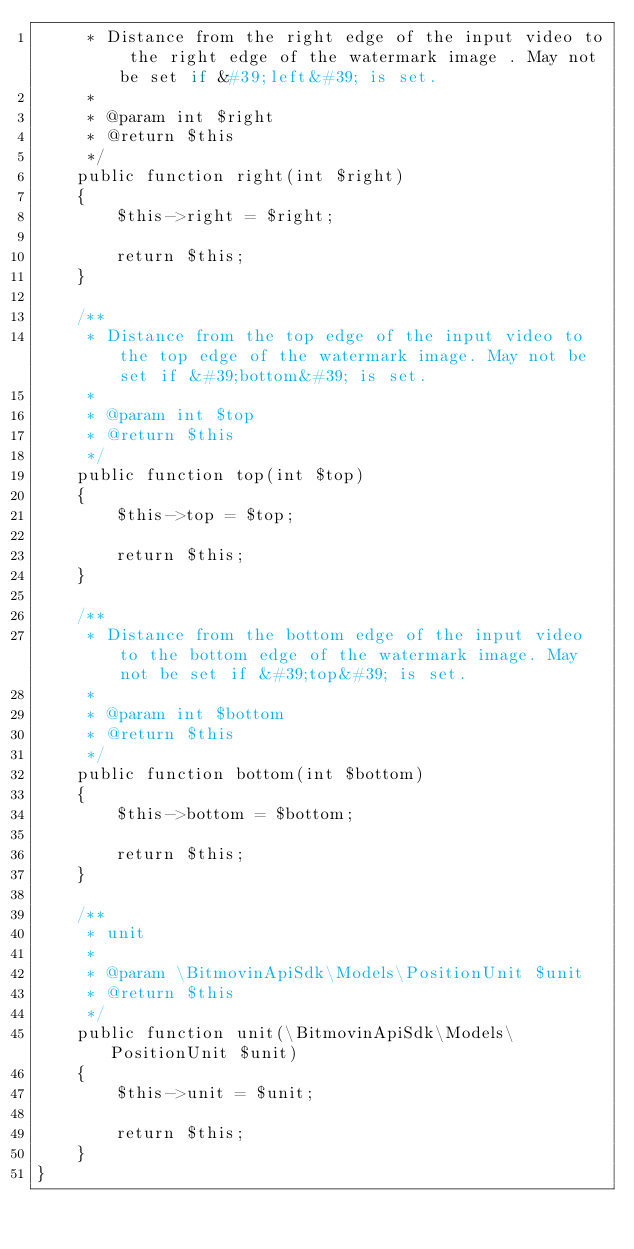Convert code to text. <code><loc_0><loc_0><loc_500><loc_500><_PHP_>     * Distance from the right edge of the input video to the right edge of the watermark image . May not be set if &#39;left&#39; is set.
     *
     * @param int $right
     * @return $this
     */
    public function right(int $right)
    {
        $this->right = $right;

        return $this;
    }

    /**
     * Distance from the top edge of the input video to the top edge of the watermark image. May not be set if &#39;bottom&#39; is set.
     *
     * @param int $top
     * @return $this
     */
    public function top(int $top)
    {
        $this->top = $top;

        return $this;
    }

    /**
     * Distance from the bottom edge of the input video to the bottom edge of the watermark image. May not be set if &#39;top&#39; is set.
     *
     * @param int $bottom
     * @return $this
     */
    public function bottom(int $bottom)
    {
        $this->bottom = $bottom;

        return $this;
    }

    /**
     * unit
     *
     * @param \BitmovinApiSdk\Models\PositionUnit $unit
     * @return $this
     */
    public function unit(\BitmovinApiSdk\Models\PositionUnit $unit)
    {
        $this->unit = $unit;

        return $this;
    }
}

</code> 